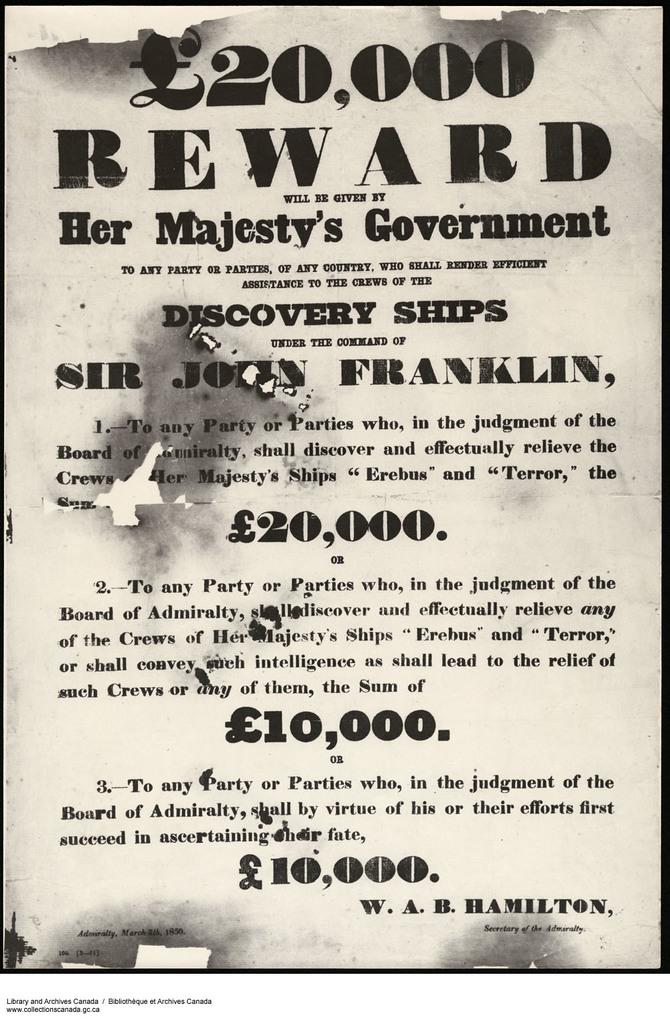<image>
Share a concise interpretation of the image provided. A 20,000 pound reward is offered on an old poster. 